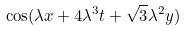<formula> <loc_0><loc_0><loc_500><loc_500>\cos ( \lambda x + 4 \lambda ^ { 3 } t + \sqrt { 3 } \lambda ^ { 2 } y )</formula> 